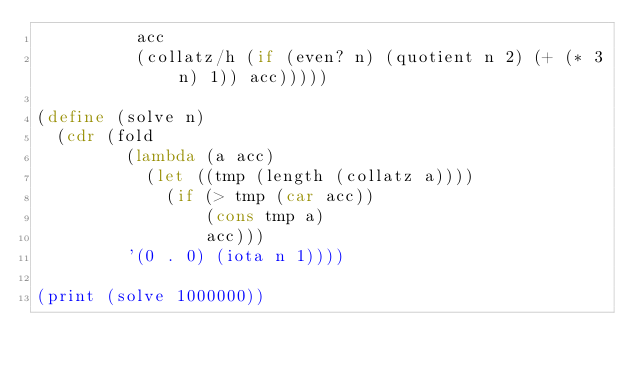<code> <loc_0><loc_0><loc_500><loc_500><_Scheme_>          acc
          (collatz/h (if (even? n) (quotient n 2) (+ (* 3 n) 1)) acc)))))

(define (solve n)
  (cdr (fold
         (lambda (a acc)
           (let ((tmp (length (collatz a))))
             (if (> tmp (car acc))
                 (cons tmp a)
                 acc)))
         '(0 . 0) (iota n 1))))

(print (solve 1000000))
</code> 